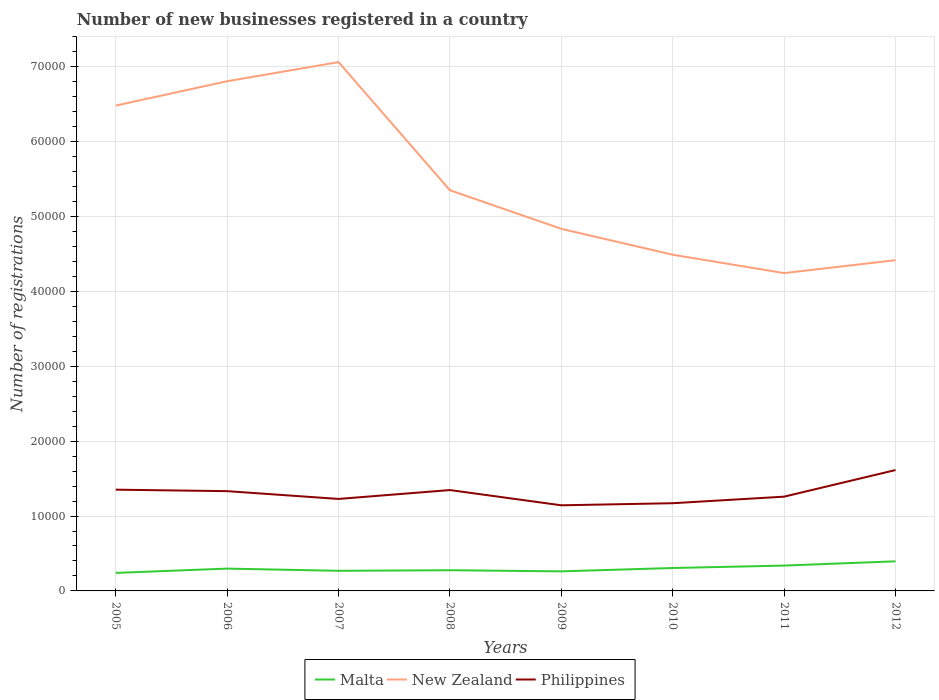Is the number of lines equal to the number of legend labels?
Your answer should be compact. Yes. Across all years, what is the maximum number of new businesses registered in Malta?
Offer a terse response. 2407. In which year was the number of new businesses registered in Malta maximum?
Your response must be concise. 2005. What is the difference between the highest and the second highest number of new businesses registered in Philippines?
Your answer should be very brief. 4708. How many lines are there?
Offer a terse response. 3. What is the difference between two consecutive major ticks on the Y-axis?
Offer a terse response. 10000. How many legend labels are there?
Your answer should be very brief. 3. What is the title of the graph?
Offer a very short reply. Number of new businesses registered in a country. What is the label or title of the Y-axis?
Your response must be concise. Number of registrations. What is the Number of registrations of Malta in 2005?
Make the answer very short. 2407. What is the Number of registrations in New Zealand in 2005?
Ensure brevity in your answer.  6.48e+04. What is the Number of registrations of Philippines in 2005?
Offer a terse response. 1.35e+04. What is the Number of registrations of Malta in 2006?
Your answer should be very brief. 2979. What is the Number of registrations in New Zealand in 2006?
Your answer should be compact. 6.81e+04. What is the Number of registrations of Philippines in 2006?
Give a very brief answer. 1.33e+04. What is the Number of registrations of Malta in 2007?
Your answer should be compact. 2685. What is the Number of registrations of New Zealand in 2007?
Provide a succinct answer. 7.06e+04. What is the Number of registrations of Philippines in 2007?
Make the answer very short. 1.23e+04. What is the Number of registrations in Malta in 2008?
Provide a succinct answer. 2764. What is the Number of registrations in New Zealand in 2008?
Provide a succinct answer. 5.35e+04. What is the Number of registrations in Philippines in 2008?
Make the answer very short. 1.35e+04. What is the Number of registrations of Malta in 2009?
Your answer should be very brief. 2612. What is the Number of registrations of New Zealand in 2009?
Offer a terse response. 4.84e+04. What is the Number of registrations of Philippines in 2009?
Provide a short and direct response. 1.14e+04. What is the Number of registrations in Malta in 2010?
Make the answer very short. 3061. What is the Number of registrations of New Zealand in 2010?
Ensure brevity in your answer.  4.49e+04. What is the Number of registrations of Philippines in 2010?
Provide a short and direct response. 1.17e+04. What is the Number of registrations of Malta in 2011?
Provide a succinct answer. 3384. What is the Number of registrations of New Zealand in 2011?
Ensure brevity in your answer.  4.24e+04. What is the Number of registrations of Philippines in 2011?
Your answer should be compact. 1.26e+04. What is the Number of registrations of Malta in 2012?
Offer a very short reply. 3953. What is the Number of registrations in New Zealand in 2012?
Your answer should be very brief. 4.42e+04. What is the Number of registrations of Philippines in 2012?
Your answer should be compact. 1.61e+04. Across all years, what is the maximum Number of registrations in Malta?
Make the answer very short. 3953. Across all years, what is the maximum Number of registrations of New Zealand?
Provide a succinct answer. 7.06e+04. Across all years, what is the maximum Number of registrations in Philippines?
Your answer should be very brief. 1.61e+04. Across all years, what is the minimum Number of registrations of Malta?
Offer a terse response. 2407. Across all years, what is the minimum Number of registrations in New Zealand?
Your response must be concise. 4.24e+04. Across all years, what is the minimum Number of registrations of Philippines?
Provide a short and direct response. 1.14e+04. What is the total Number of registrations in Malta in the graph?
Ensure brevity in your answer.  2.38e+04. What is the total Number of registrations of New Zealand in the graph?
Ensure brevity in your answer.  4.37e+05. What is the total Number of registrations in Philippines in the graph?
Ensure brevity in your answer.  1.04e+05. What is the difference between the Number of registrations of Malta in 2005 and that in 2006?
Give a very brief answer. -572. What is the difference between the Number of registrations in New Zealand in 2005 and that in 2006?
Your response must be concise. -3253. What is the difference between the Number of registrations of Philippines in 2005 and that in 2006?
Your answer should be very brief. 198. What is the difference between the Number of registrations in Malta in 2005 and that in 2007?
Your answer should be compact. -278. What is the difference between the Number of registrations of New Zealand in 2005 and that in 2007?
Ensure brevity in your answer.  -5806. What is the difference between the Number of registrations in Philippines in 2005 and that in 2007?
Provide a succinct answer. 1238. What is the difference between the Number of registrations in Malta in 2005 and that in 2008?
Offer a terse response. -357. What is the difference between the Number of registrations in New Zealand in 2005 and that in 2008?
Ensure brevity in your answer.  1.13e+04. What is the difference between the Number of registrations of Philippines in 2005 and that in 2008?
Offer a terse response. 53. What is the difference between the Number of registrations in Malta in 2005 and that in 2009?
Offer a terse response. -205. What is the difference between the Number of registrations of New Zealand in 2005 and that in 2009?
Ensure brevity in your answer.  1.65e+04. What is the difference between the Number of registrations in Philippines in 2005 and that in 2009?
Offer a very short reply. 2088. What is the difference between the Number of registrations of Malta in 2005 and that in 2010?
Your answer should be compact. -654. What is the difference between the Number of registrations in New Zealand in 2005 and that in 2010?
Ensure brevity in your answer.  1.99e+04. What is the difference between the Number of registrations in Philippines in 2005 and that in 2010?
Provide a succinct answer. 1809. What is the difference between the Number of registrations of Malta in 2005 and that in 2011?
Offer a very short reply. -977. What is the difference between the Number of registrations of New Zealand in 2005 and that in 2011?
Provide a succinct answer. 2.24e+04. What is the difference between the Number of registrations in Philippines in 2005 and that in 2011?
Provide a short and direct response. 933. What is the difference between the Number of registrations of Malta in 2005 and that in 2012?
Ensure brevity in your answer.  -1546. What is the difference between the Number of registrations in New Zealand in 2005 and that in 2012?
Provide a short and direct response. 2.06e+04. What is the difference between the Number of registrations in Philippines in 2005 and that in 2012?
Your response must be concise. -2620. What is the difference between the Number of registrations in Malta in 2006 and that in 2007?
Ensure brevity in your answer.  294. What is the difference between the Number of registrations of New Zealand in 2006 and that in 2007?
Your answer should be compact. -2553. What is the difference between the Number of registrations of Philippines in 2006 and that in 2007?
Your response must be concise. 1040. What is the difference between the Number of registrations in Malta in 2006 and that in 2008?
Make the answer very short. 215. What is the difference between the Number of registrations of New Zealand in 2006 and that in 2008?
Give a very brief answer. 1.46e+04. What is the difference between the Number of registrations of Philippines in 2006 and that in 2008?
Ensure brevity in your answer.  -145. What is the difference between the Number of registrations of Malta in 2006 and that in 2009?
Give a very brief answer. 367. What is the difference between the Number of registrations of New Zealand in 2006 and that in 2009?
Ensure brevity in your answer.  1.97e+04. What is the difference between the Number of registrations in Philippines in 2006 and that in 2009?
Offer a very short reply. 1890. What is the difference between the Number of registrations in Malta in 2006 and that in 2010?
Keep it short and to the point. -82. What is the difference between the Number of registrations in New Zealand in 2006 and that in 2010?
Your answer should be compact. 2.32e+04. What is the difference between the Number of registrations of Philippines in 2006 and that in 2010?
Your answer should be very brief. 1611. What is the difference between the Number of registrations in Malta in 2006 and that in 2011?
Make the answer very short. -405. What is the difference between the Number of registrations in New Zealand in 2006 and that in 2011?
Your response must be concise. 2.56e+04. What is the difference between the Number of registrations of Philippines in 2006 and that in 2011?
Your answer should be very brief. 735. What is the difference between the Number of registrations of Malta in 2006 and that in 2012?
Your answer should be very brief. -974. What is the difference between the Number of registrations of New Zealand in 2006 and that in 2012?
Ensure brevity in your answer.  2.39e+04. What is the difference between the Number of registrations in Philippines in 2006 and that in 2012?
Make the answer very short. -2818. What is the difference between the Number of registrations in Malta in 2007 and that in 2008?
Offer a terse response. -79. What is the difference between the Number of registrations of New Zealand in 2007 and that in 2008?
Your response must be concise. 1.71e+04. What is the difference between the Number of registrations of Philippines in 2007 and that in 2008?
Provide a succinct answer. -1185. What is the difference between the Number of registrations of Malta in 2007 and that in 2009?
Offer a very short reply. 73. What is the difference between the Number of registrations of New Zealand in 2007 and that in 2009?
Make the answer very short. 2.23e+04. What is the difference between the Number of registrations of Philippines in 2007 and that in 2009?
Make the answer very short. 850. What is the difference between the Number of registrations of Malta in 2007 and that in 2010?
Keep it short and to the point. -376. What is the difference between the Number of registrations in New Zealand in 2007 and that in 2010?
Give a very brief answer. 2.57e+04. What is the difference between the Number of registrations in Philippines in 2007 and that in 2010?
Offer a very short reply. 571. What is the difference between the Number of registrations of Malta in 2007 and that in 2011?
Provide a short and direct response. -699. What is the difference between the Number of registrations of New Zealand in 2007 and that in 2011?
Your response must be concise. 2.82e+04. What is the difference between the Number of registrations of Philippines in 2007 and that in 2011?
Keep it short and to the point. -305. What is the difference between the Number of registrations in Malta in 2007 and that in 2012?
Your answer should be very brief. -1268. What is the difference between the Number of registrations of New Zealand in 2007 and that in 2012?
Your response must be concise. 2.65e+04. What is the difference between the Number of registrations in Philippines in 2007 and that in 2012?
Keep it short and to the point. -3858. What is the difference between the Number of registrations of Malta in 2008 and that in 2009?
Provide a short and direct response. 152. What is the difference between the Number of registrations in New Zealand in 2008 and that in 2009?
Keep it short and to the point. 5154. What is the difference between the Number of registrations of Philippines in 2008 and that in 2009?
Make the answer very short. 2035. What is the difference between the Number of registrations in Malta in 2008 and that in 2010?
Your answer should be compact. -297. What is the difference between the Number of registrations of New Zealand in 2008 and that in 2010?
Make the answer very short. 8614. What is the difference between the Number of registrations in Philippines in 2008 and that in 2010?
Ensure brevity in your answer.  1756. What is the difference between the Number of registrations in Malta in 2008 and that in 2011?
Give a very brief answer. -620. What is the difference between the Number of registrations of New Zealand in 2008 and that in 2011?
Your answer should be compact. 1.11e+04. What is the difference between the Number of registrations in Philippines in 2008 and that in 2011?
Ensure brevity in your answer.  880. What is the difference between the Number of registrations in Malta in 2008 and that in 2012?
Ensure brevity in your answer.  -1189. What is the difference between the Number of registrations in New Zealand in 2008 and that in 2012?
Provide a short and direct response. 9343. What is the difference between the Number of registrations in Philippines in 2008 and that in 2012?
Provide a short and direct response. -2673. What is the difference between the Number of registrations in Malta in 2009 and that in 2010?
Your response must be concise. -449. What is the difference between the Number of registrations of New Zealand in 2009 and that in 2010?
Offer a very short reply. 3460. What is the difference between the Number of registrations in Philippines in 2009 and that in 2010?
Provide a short and direct response. -279. What is the difference between the Number of registrations of Malta in 2009 and that in 2011?
Keep it short and to the point. -772. What is the difference between the Number of registrations in New Zealand in 2009 and that in 2011?
Give a very brief answer. 5911. What is the difference between the Number of registrations in Philippines in 2009 and that in 2011?
Provide a short and direct response. -1155. What is the difference between the Number of registrations of Malta in 2009 and that in 2012?
Provide a short and direct response. -1341. What is the difference between the Number of registrations in New Zealand in 2009 and that in 2012?
Offer a terse response. 4189. What is the difference between the Number of registrations of Philippines in 2009 and that in 2012?
Keep it short and to the point. -4708. What is the difference between the Number of registrations of Malta in 2010 and that in 2011?
Your response must be concise. -323. What is the difference between the Number of registrations in New Zealand in 2010 and that in 2011?
Your answer should be very brief. 2451. What is the difference between the Number of registrations in Philippines in 2010 and that in 2011?
Offer a terse response. -876. What is the difference between the Number of registrations in Malta in 2010 and that in 2012?
Offer a terse response. -892. What is the difference between the Number of registrations in New Zealand in 2010 and that in 2012?
Your answer should be very brief. 729. What is the difference between the Number of registrations of Philippines in 2010 and that in 2012?
Your answer should be compact. -4429. What is the difference between the Number of registrations in Malta in 2011 and that in 2012?
Your answer should be compact. -569. What is the difference between the Number of registrations of New Zealand in 2011 and that in 2012?
Your answer should be compact. -1722. What is the difference between the Number of registrations in Philippines in 2011 and that in 2012?
Provide a succinct answer. -3553. What is the difference between the Number of registrations in Malta in 2005 and the Number of registrations in New Zealand in 2006?
Make the answer very short. -6.57e+04. What is the difference between the Number of registrations in Malta in 2005 and the Number of registrations in Philippines in 2006?
Ensure brevity in your answer.  -1.09e+04. What is the difference between the Number of registrations of New Zealand in 2005 and the Number of registrations of Philippines in 2006?
Keep it short and to the point. 5.15e+04. What is the difference between the Number of registrations in Malta in 2005 and the Number of registrations in New Zealand in 2007?
Your response must be concise. -6.82e+04. What is the difference between the Number of registrations in Malta in 2005 and the Number of registrations in Philippines in 2007?
Provide a short and direct response. -9878. What is the difference between the Number of registrations of New Zealand in 2005 and the Number of registrations of Philippines in 2007?
Offer a terse response. 5.25e+04. What is the difference between the Number of registrations of Malta in 2005 and the Number of registrations of New Zealand in 2008?
Make the answer very short. -5.11e+04. What is the difference between the Number of registrations in Malta in 2005 and the Number of registrations in Philippines in 2008?
Provide a succinct answer. -1.11e+04. What is the difference between the Number of registrations of New Zealand in 2005 and the Number of registrations of Philippines in 2008?
Make the answer very short. 5.13e+04. What is the difference between the Number of registrations of Malta in 2005 and the Number of registrations of New Zealand in 2009?
Keep it short and to the point. -4.60e+04. What is the difference between the Number of registrations of Malta in 2005 and the Number of registrations of Philippines in 2009?
Ensure brevity in your answer.  -9028. What is the difference between the Number of registrations in New Zealand in 2005 and the Number of registrations in Philippines in 2009?
Give a very brief answer. 5.34e+04. What is the difference between the Number of registrations in Malta in 2005 and the Number of registrations in New Zealand in 2010?
Keep it short and to the point. -4.25e+04. What is the difference between the Number of registrations of Malta in 2005 and the Number of registrations of Philippines in 2010?
Offer a terse response. -9307. What is the difference between the Number of registrations in New Zealand in 2005 and the Number of registrations in Philippines in 2010?
Your response must be concise. 5.31e+04. What is the difference between the Number of registrations of Malta in 2005 and the Number of registrations of New Zealand in 2011?
Offer a terse response. -4.00e+04. What is the difference between the Number of registrations in Malta in 2005 and the Number of registrations in Philippines in 2011?
Ensure brevity in your answer.  -1.02e+04. What is the difference between the Number of registrations of New Zealand in 2005 and the Number of registrations of Philippines in 2011?
Offer a very short reply. 5.22e+04. What is the difference between the Number of registrations in Malta in 2005 and the Number of registrations in New Zealand in 2012?
Give a very brief answer. -4.18e+04. What is the difference between the Number of registrations in Malta in 2005 and the Number of registrations in Philippines in 2012?
Give a very brief answer. -1.37e+04. What is the difference between the Number of registrations of New Zealand in 2005 and the Number of registrations of Philippines in 2012?
Give a very brief answer. 4.87e+04. What is the difference between the Number of registrations in Malta in 2006 and the Number of registrations in New Zealand in 2007?
Provide a short and direct response. -6.76e+04. What is the difference between the Number of registrations in Malta in 2006 and the Number of registrations in Philippines in 2007?
Your response must be concise. -9306. What is the difference between the Number of registrations in New Zealand in 2006 and the Number of registrations in Philippines in 2007?
Keep it short and to the point. 5.58e+04. What is the difference between the Number of registrations in Malta in 2006 and the Number of registrations in New Zealand in 2008?
Provide a succinct answer. -5.05e+04. What is the difference between the Number of registrations in Malta in 2006 and the Number of registrations in Philippines in 2008?
Your answer should be compact. -1.05e+04. What is the difference between the Number of registrations in New Zealand in 2006 and the Number of registrations in Philippines in 2008?
Your answer should be very brief. 5.46e+04. What is the difference between the Number of registrations in Malta in 2006 and the Number of registrations in New Zealand in 2009?
Give a very brief answer. -4.54e+04. What is the difference between the Number of registrations in Malta in 2006 and the Number of registrations in Philippines in 2009?
Your response must be concise. -8456. What is the difference between the Number of registrations in New Zealand in 2006 and the Number of registrations in Philippines in 2009?
Keep it short and to the point. 5.66e+04. What is the difference between the Number of registrations in Malta in 2006 and the Number of registrations in New Zealand in 2010?
Ensure brevity in your answer.  -4.19e+04. What is the difference between the Number of registrations of Malta in 2006 and the Number of registrations of Philippines in 2010?
Provide a short and direct response. -8735. What is the difference between the Number of registrations of New Zealand in 2006 and the Number of registrations of Philippines in 2010?
Give a very brief answer. 5.64e+04. What is the difference between the Number of registrations in Malta in 2006 and the Number of registrations in New Zealand in 2011?
Provide a succinct answer. -3.95e+04. What is the difference between the Number of registrations of Malta in 2006 and the Number of registrations of Philippines in 2011?
Your response must be concise. -9611. What is the difference between the Number of registrations of New Zealand in 2006 and the Number of registrations of Philippines in 2011?
Offer a very short reply. 5.55e+04. What is the difference between the Number of registrations in Malta in 2006 and the Number of registrations in New Zealand in 2012?
Provide a short and direct response. -4.12e+04. What is the difference between the Number of registrations in Malta in 2006 and the Number of registrations in Philippines in 2012?
Provide a short and direct response. -1.32e+04. What is the difference between the Number of registrations of New Zealand in 2006 and the Number of registrations of Philippines in 2012?
Offer a terse response. 5.19e+04. What is the difference between the Number of registrations of Malta in 2007 and the Number of registrations of New Zealand in 2008?
Offer a terse response. -5.08e+04. What is the difference between the Number of registrations in Malta in 2007 and the Number of registrations in Philippines in 2008?
Your answer should be compact. -1.08e+04. What is the difference between the Number of registrations in New Zealand in 2007 and the Number of registrations in Philippines in 2008?
Your response must be concise. 5.72e+04. What is the difference between the Number of registrations of Malta in 2007 and the Number of registrations of New Zealand in 2009?
Keep it short and to the point. -4.57e+04. What is the difference between the Number of registrations in Malta in 2007 and the Number of registrations in Philippines in 2009?
Your answer should be compact. -8750. What is the difference between the Number of registrations of New Zealand in 2007 and the Number of registrations of Philippines in 2009?
Offer a very short reply. 5.92e+04. What is the difference between the Number of registrations in Malta in 2007 and the Number of registrations in New Zealand in 2010?
Give a very brief answer. -4.22e+04. What is the difference between the Number of registrations in Malta in 2007 and the Number of registrations in Philippines in 2010?
Your answer should be compact. -9029. What is the difference between the Number of registrations in New Zealand in 2007 and the Number of registrations in Philippines in 2010?
Offer a terse response. 5.89e+04. What is the difference between the Number of registrations in Malta in 2007 and the Number of registrations in New Zealand in 2011?
Your response must be concise. -3.98e+04. What is the difference between the Number of registrations in Malta in 2007 and the Number of registrations in Philippines in 2011?
Give a very brief answer. -9905. What is the difference between the Number of registrations of New Zealand in 2007 and the Number of registrations of Philippines in 2011?
Provide a short and direct response. 5.80e+04. What is the difference between the Number of registrations of Malta in 2007 and the Number of registrations of New Zealand in 2012?
Offer a very short reply. -4.15e+04. What is the difference between the Number of registrations of Malta in 2007 and the Number of registrations of Philippines in 2012?
Your answer should be very brief. -1.35e+04. What is the difference between the Number of registrations of New Zealand in 2007 and the Number of registrations of Philippines in 2012?
Your response must be concise. 5.45e+04. What is the difference between the Number of registrations in Malta in 2008 and the Number of registrations in New Zealand in 2009?
Provide a succinct answer. -4.56e+04. What is the difference between the Number of registrations in Malta in 2008 and the Number of registrations in Philippines in 2009?
Offer a terse response. -8671. What is the difference between the Number of registrations in New Zealand in 2008 and the Number of registrations in Philippines in 2009?
Offer a terse response. 4.21e+04. What is the difference between the Number of registrations in Malta in 2008 and the Number of registrations in New Zealand in 2010?
Make the answer very short. -4.21e+04. What is the difference between the Number of registrations of Malta in 2008 and the Number of registrations of Philippines in 2010?
Give a very brief answer. -8950. What is the difference between the Number of registrations in New Zealand in 2008 and the Number of registrations in Philippines in 2010?
Your answer should be very brief. 4.18e+04. What is the difference between the Number of registrations of Malta in 2008 and the Number of registrations of New Zealand in 2011?
Your answer should be compact. -3.97e+04. What is the difference between the Number of registrations of Malta in 2008 and the Number of registrations of Philippines in 2011?
Offer a terse response. -9826. What is the difference between the Number of registrations in New Zealand in 2008 and the Number of registrations in Philippines in 2011?
Your answer should be very brief. 4.09e+04. What is the difference between the Number of registrations of Malta in 2008 and the Number of registrations of New Zealand in 2012?
Offer a very short reply. -4.14e+04. What is the difference between the Number of registrations in Malta in 2008 and the Number of registrations in Philippines in 2012?
Your answer should be very brief. -1.34e+04. What is the difference between the Number of registrations of New Zealand in 2008 and the Number of registrations of Philippines in 2012?
Give a very brief answer. 3.74e+04. What is the difference between the Number of registrations of Malta in 2009 and the Number of registrations of New Zealand in 2010?
Offer a very short reply. -4.23e+04. What is the difference between the Number of registrations in Malta in 2009 and the Number of registrations in Philippines in 2010?
Keep it short and to the point. -9102. What is the difference between the Number of registrations of New Zealand in 2009 and the Number of registrations of Philippines in 2010?
Your response must be concise. 3.66e+04. What is the difference between the Number of registrations in Malta in 2009 and the Number of registrations in New Zealand in 2011?
Keep it short and to the point. -3.98e+04. What is the difference between the Number of registrations in Malta in 2009 and the Number of registrations in Philippines in 2011?
Your answer should be very brief. -9978. What is the difference between the Number of registrations in New Zealand in 2009 and the Number of registrations in Philippines in 2011?
Provide a succinct answer. 3.58e+04. What is the difference between the Number of registrations of Malta in 2009 and the Number of registrations of New Zealand in 2012?
Provide a succinct answer. -4.16e+04. What is the difference between the Number of registrations in Malta in 2009 and the Number of registrations in Philippines in 2012?
Keep it short and to the point. -1.35e+04. What is the difference between the Number of registrations of New Zealand in 2009 and the Number of registrations of Philippines in 2012?
Make the answer very short. 3.22e+04. What is the difference between the Number of registrations of Malta in 2010 and the Number of registrations of New Zealand in 2011?
Keep it short and to the point. -3.94e+04. What is the difference between the Number of registrations in Malta in 2010 and the Number of registrations in Philippines in 2011?
Make the answer very short. -9529. What is the difference between the Number of registrations in New Zealand in 2010 and the Number of registrations in Philippines in 2011?
Your answer should be compact. 3.23e+04. What is the difference between the Number of registrations of Malta in 2010 and the Number of registrations of New Zealand in 2012?
Ensure brevity in your answer.  -4.11e+04. What is the difference between the Number of registrations in Malta in 2010 and the Number of registrations in Philippines in 2012?
Offer a terse response. -1.31e+04. What is the difference between the Number of registrations in New Zealand in 2010 and the Number of registrations in Philippines in 2012?
Offer a very short reply. 2.88e+04. What is the difference between the Number of registrations in Malta in 2011 and the Number of registrations in New Zealand in 2012?
Your response must be concise. -4.08e+04. What is the difference between the Number of registrations of Malta in 2011 and the Number of registrations of Philippines in 2012?
Ensure brevity in your answer.  -1.28e+04. What is the difference between the Number of registrations of New Zealand in 2011 and the Number of registrations of Philippines in 2012?
Make the answer very short. 2.63e+04. What is the average Number of registrations in Malta per year?
Your response must be concise. 2980.62. What is the average Number of registrations in New Zealand per year?
Your response must be concise. 5.46e+04. What is the average Number of registrations of Philippines per year?
Give a very brief answer. 1.31e+04. In the year 2005, what is the difference between the Number of registrations of Malta and Number of registrations of New Zealand?
Ensure brevity in your answer.  -6.24e+04. In the year 2005, what is the difference between the Number of registrations of Malta and Number of registrations of Philippines?
Offer a very short reply. -1.11e+04. In the year 2005, what is the difference between the Number of registrations in New Zealand and Number of registrations in Philippines?
Make the answer very short. 5.13e+04. In the year 2006, what is the difference between the Number of registrations of Malta and Number of registrations of New Zealand?
Keep it short and to the point. -6.51e+04. In the year 2006, what is the difference between the Number of registrations in Malta and Number of registrations in Philippines?
Your answer should be compact. -1.03e+04. In the year 2006, what is the difference between the Number of registrations of New Zealand and Number of registrations of Philippines?
Your answer should be compact. 5.47e+04. In the year 2007, what is the difference between the Number of registrations in Malta and Number of registrations in New Zealand?
Make the answer very short. -6.79e+04. In the year 2007, what is the difference between the Number of registrations in Malta and Number of registrations in Philippines?
Ensure brevity in your answer.  -9600. In the year 2007, what is the difference between the Number of registrations of New Zealand and Number of registrations of Philippines?
Provide a succinct answer. 5.83e+04. In the year 2008, what is the difference between the Number of registrations of Malta and Number of registrations of New Zealand?
Ensure brevity in your answer.  -5.07e+04. In the year 2008, what is the difference between the Number of registrations of Malta and Number of registrations of Philippines?
Your answer should be compact. -1.07e+04. In the year 2008, what is the difference between the Number of registrations of New Zealand and Number of registrations of Philippines?
Your answer should be compact. 4.00e+04. In the year 2009, what is the difference between the Number of registrations of Malta and Number of registrations of New Zealand?
Your response must be concise. -4.57e+04. In the year 2009, what is the difference between the Number of registrations of Malta and Number of registrations of Philippines?
Make the answer very short. -8823. In the year 2009, what is the difference between the Number of registrations in New Zealand and Number of registrations in Philippines?
Give a very brief answer. 3.69e+04. In the year 2010, what is the difference between the Number of registrations in Malta and Number of registrations in New Zealand?
Provide a short and direct response. -4.18e+04. In the year 2010, what is the difference between the Number of registrations in Malta and Number of registrations in Philippines?
Your answer should be compact. -8653. In the year 2010, what is the difference between the Number of registrations in New Zealand and Number of registrations in Philippines?
Provide a succinct answer. 3.32e+04. In the year 2011, what is the difference between the Number of registrations in Malta and Number of registrations in New Zealand?
Your response must be concise. -3.91e+04. In the year 2011, what is the difference between the Number of registrations of Malta and Number of registrations of Philippines?
Make the answer very short. -9206. In the year 2011, what is the difference between the Number of registrations in New Zealand and Number of registrations in Philippines?
Your response must be concise. 2.99e+04. In the year 2012, what is the difference between the Number of registrations of Malta and Number of registrations of New Zealand?
Make the answer very short. -4.02e+04. In the year 2012, what is the difference between the Number of registrations of Malta and Number of registrations of Philippines?
Provide a short and direct response. -1.22e+04. In the year 2012, what is the difference between the Number of registrations in New Zealand and Number of registrations in Philippines?
Your answer should be compact. 2.80e+04. What is the ratio of the Number of registrations of Malta in 2005 to that in 2006?
Offer a terse response. 0.81. What is the ratio of the Number of registrations in New Zealand in 2005 to that in 2006?
Offer a terse response. 0.95. What is the ratio of the Number of registrations in Philippines in 2005 to that in 2006?
Provide a short and direct response. 1.01. What is the ratio of the Number of registrations of Malta in 2005 to that in 2007?
Keep it short and to the point. 0.9. What is the ratio of the Number of registrations in New Zealand in 2005 to that in 2007?
Your response must be concise. 0.92. What is the ratio of the Number of registrations in Philippines in 2005 to that in 2007?
Your response must be concise. 1.1. What is the ratio of the Number of registrations in Malta in 2005 to that in 2008?
Your response must be concise. 0.87. What is the ratio of the Number of registrations of New Zealand in 2005 to that in 2008?
Provide a succinct answer. 1.21. What is the ratio of the Number of registrations of Malta in 2005 to that in 2009?
Make the answer very short. 0.92. What is the ratio of the Number of registrations in New Zealand in 2005 to that in 2009?
Your answer should be compact. 1.34. What is the ratio of the Number of registrations in Philippines in 2005 to that in 2009?
Provide a succinct answer. 1.18. What is the ratio of the Number of registrations in Malta in 2005 to that in 2010?
Offer a terse response. 0.79. What is the ratio of the Number of registrations in New Zealand in 2005 to that in 2010?
Ensure brevity in your answer.  1.44. What is the ratio of the Number of registrations in Philippines in 2005 to that in 2010?
Keep it short and to the point. 1.15. What is the ratio of the Number of registrations in Malta in 2005 to that in 2011?
Your response must be concise. 0.71. What is the ratio of the Number of registrations of New Zealand in 2005 to that in 2011?
Give a very brief answer. 1.53. What is the ratio of the Number of registrations of Philippines in 2005 to that in 2011?
Offer a very short reply. 1.07. What is the ratio of the Number of registrations in Malta in 2005 to that in 2012?
Provide a succinct answer. 0.61. What is the ratio of the Number of registrations in New Zealand in 2005 to that in 2012?
Provide a succinct answer. 1.47. What is the ratio of the Number of registrations of Philippines in 2005 to that in 2012?
Make the answer very short. 0.84. What is the ratio of the Number of registrations in Malta in 2006 to that in 2007?
Provide a succinct answer. 1.11. What is the ratio of the Number of registrations in New Zealand in 2006 to that in 2007?
Offer a terse response. 0.96. What is the ratio of the Number of registrations of Philippines in 2006 to that in 2007?
Provide a short and direct response. 1.08. What is the ratio of the Number of registrations in Malta in 2006 to that in 2008?
Your answer should be very brief. 1.08. What is the ratio of the Number of registrations in New Zealand in 2006 to that in 2008?
Offer a very short reply. 1.27. What is the ratio of the Number of registrations of Philippines in 2006 to that in 2008?
Give a very brief answer. 0.99. What is the ratio of the Number of registrations in Malta in 2006 to that in 2009?
Provide a short and direct response. 1.14. What is the ratio of the Number of registrations in New Zealand in 2006 to that in 2009?
Your answer should be compact. 1.41. What is the ratio of the Number of registrations in Philippines in 2006 to that in 2009?
Provide a short and direct response. 1.17. What is the ratio of the Number of registrations in Malta in 2006 to that in 2010?
Offer a very short reply. 0.97. What is the ratio of the Number of registrations of New Zealand in 2006 to that in 2010?
Your answer should be compact. 1.52. What is the ratio of the Number of registrations in Philippines in 2006 to that in 2010?
Make the answer very short. 1.14. What is the ratio of the Number of registrations of Malta in 2006 to that in 2011?
Ensure brevity in your answer.  0.88. What is the ratio of the Number of registrations in New Zealand in 2006 to that in 2011?
Ensure brevity in your answer.  1.6. What is the ratio of the Number of registrations in Philippines in 2006 to that in 2011?
Your answer should be compact. 1.06. What is the ratio of the Number of registrations of Malta in 2006 to that in 2012?
Keep it short and to the point. 0.75. What is the ratio of the Number of registrations of New Zealand in 2006 to that in 2012?
Ensure brevity in your answer.  1.54. What is the ratio of the Number of registrations in Philippines in 2006 to that in 2012?
Provide a succinct answer. 0.83. What is the ratio of the Number of registrations in Malta in 2007 to that in 2008?
Your answer should be compact. 0.97. What is the ratio of the Number of registrations of New Zealand in 2007 to that in 2008?
Your answer should be compact. 1.32. What is the ratio of the Number of registrations of Philippines in 2007 to that in 2008?
Make the answer very short. 0.91. What is the ratio of the Number of registrations in Malta in 2007 to that in 2009?
Your response must be concise. 1.03. What is the ratio of the Number of registrations of New Zealand in 2007 to that in 2009?
Ensure brevity in your answer.  1.46. What is the ratio of the Number of registrations of Philippines in 2007 to that in 2009?
Provide a succinct answer. 1.07. What is the ratio of the Number of registrations in Malta in 2007 to that in 2010?
Offer a very short reply. 0.88. What is the ratio of the Number of registrations in New Zealand in 2007 to that in 2010?
Your response must be concise. 1.57. What is the ratio of the Number of registrations of Philippines in 2007 to that in 2010?
Ensure brevity in your answer.  1.05. What is the ratio of the Number of registrations of Malta in 2007 to that in 2011?
Your answer should be very brief. 0.79. What is the ratio of the Number of registrations in New Zealand in 2007 to that in 2011?
Offer a terse response. 1.66. What is the ratio of the Number of registrations of Philippines in 2007 to that in 2011?
Make the answer very short. 0.98. What is the ratio of the Number of registrations of Malta in 2007 to that in 2012?
Keep it short and to the point. 0.68. What is the ratio of the Number of registrations of New Zealand in 2007 to that in 2012?
Give a very brief answer. 1.6. What is the ratio of the Number of registrations in Philippines in 2007 to that in 2012?
Your answer should be very brief. 0.76. What is the ratio of the Number of registrations in Malta in 2008 to that in 2009?
Provide a succinct answer. 1.06. What is the ratio of the Number of registrations in New Zealand in 2008 to that in 2009?
Ensure brevity in your answer.  1.11. What is the ratio of the Number of registrations in Philippines in 2008 to that in 2009?
Your answer should be compact. 1.18. What is the ratio of the Number of registrations of Malta in 2008 to that in 2010?
Offer a very short reply. 0.9. What is the ratio of the Number of registrations in New Zealand in 2008 to that in 2010?
Offer a terse response. 1.19. What is the ratio of the Number of registrations in Philippines in 2008 to that in 2010?
Give a very brief answer. 1.15. What is the ratio of the Number of registrations of Malta in 2008 to that in 2011?
Ensure brevity in your answer.  0.82. What is the ratio of the Number of registrations in New Zealand in 2008 to that in 2011?
Keep it short and to the point. 1.26. What is the ratio of the Number of registrations of Philippines in 2008 to that in 2011?
Offer a very short reply. 1.07. What is the ratio of the Number of registrations of Malta in 2008 to that in 2012?
Offer a very short reply. 0.7. What is the ratio of the Number of registrations in New Zealand in 2008 to that in 2012?
Offer a very short reply. 1.21. What is the ratio of the Number of registrations in Philippines in 2008 to that in 2012?
Your response must be concise. 0.83. What is the ratio of the Number of registrations of Malta in 2009 to that in 2010?
Your answer should be compact. 0.85. What is the ratio of the Number of registrations of New Zealand in 2009 to that in 2010?
Give a very brief answer. 1.08. What is the ratio of the Number of registrations of Philippines in 2009 to that in 2010?
Your answer should be compact. 0.98. What is the ratio of the Number of registrations in Malta in 2009 to that in 2011?
Provide a succinct answer. 0.77. What is the ratio of the Number of registrations in New Zealand in 2009 to that in 2011?
Your response must be concise. 1.14. What is the ratio of the Number of registrations in Philippines in 2009 to that in 2011?
Give a very brief answer. 0.91. What is the ratio of the Number of registrations of Malta in 2009 to that in 2012?
Offer a very short reply. 0.66. What is the ratio of the Number of registrations of New Zealand in 2009 to that in 2012?
Keep it short and to the point. 1.09. What is the ratio of the Number of registrations of Philippines in 2009 to that in 2012?
Give a very brief answer. 0.71. What is the ratio of the Number of registrations in Malta in 2010 to that in 2011?
Give a very brief answer. 0.9. What is the ratio of the Number of registrations of New Zealand in 2010 to that in 2011?
Provide a short and direct response. 1.06. What is the ratio of the Number of registrations in Philippines in 2010 to that in 2011?
Ensure brevity in your answer.  0.93. What is the ratio of the Number of registrations of Malta in 2010 to that in 2012?
Offer a terse response. 0.77. What is the ratio of the Number of registrations of New Zealand in 2010 to that in 2012?
Provide a succinct answer. 1.02. What is the ratio of the Number of registrations of Philippines in 2010 to that in 2012?
Offer a terse response. 0.73. What is the ratio of the Number of registrations of Malta in 2011 to that in 2012?
Provide a succinct answer. 0.86. What is the ratio of the Number of registrations in Philippines in 2011 to that in 2012?
Ensure brevity in your answer.  0.78. What is the difference between the highest and the second highest Number of registrations of Malta?
Provide a short and direct response. 569. What is the difference between the highest and the second highest Number of registrations of New Zealand?
Provide a short and direct response. 2553. What is the difference between the highest and the second highest Number of registrations in Philippines?
Keep it short and to the point. 2620. What is the difference between the highest and the lowest Number of registrations of Malta?
Your answer should be very brief. 1546. What is the difference between the highest and the lowest Number of registrations of New Zealand?
Ensure brevity in your answer.  2.82e+04. What is the difference between the highest and the lowest Number of registrations of Philippines?
Make the answer very short. 4708. 